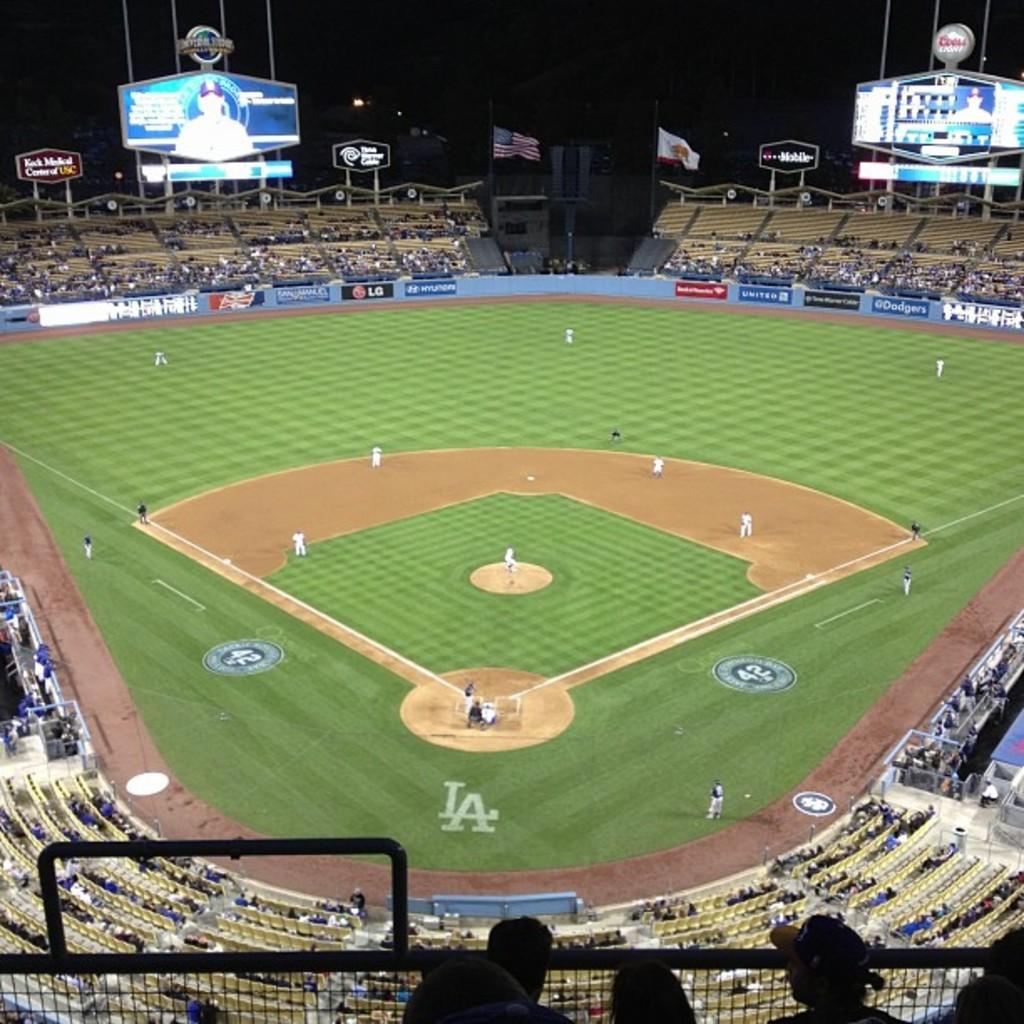What two letters are behind the home plate area?
Your response must be concise. La. How many bases are on this field?
Offer a very short reply. Answering does not require reading text in the image. 